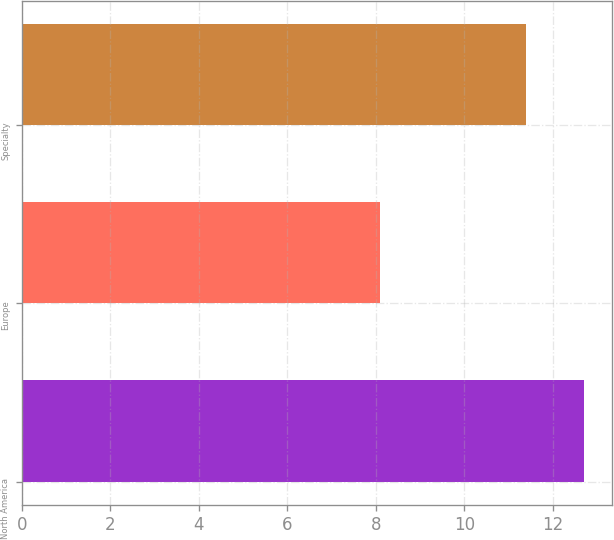Convert chart. <chart><loc_0><loc_0><loc_500><loc_500><bar_chart><fcel>North America<fcel>Europe<fcel>Specialty<nl><fcel>12.7<fcel>8.1<fcel>11.4<nl></chart> 